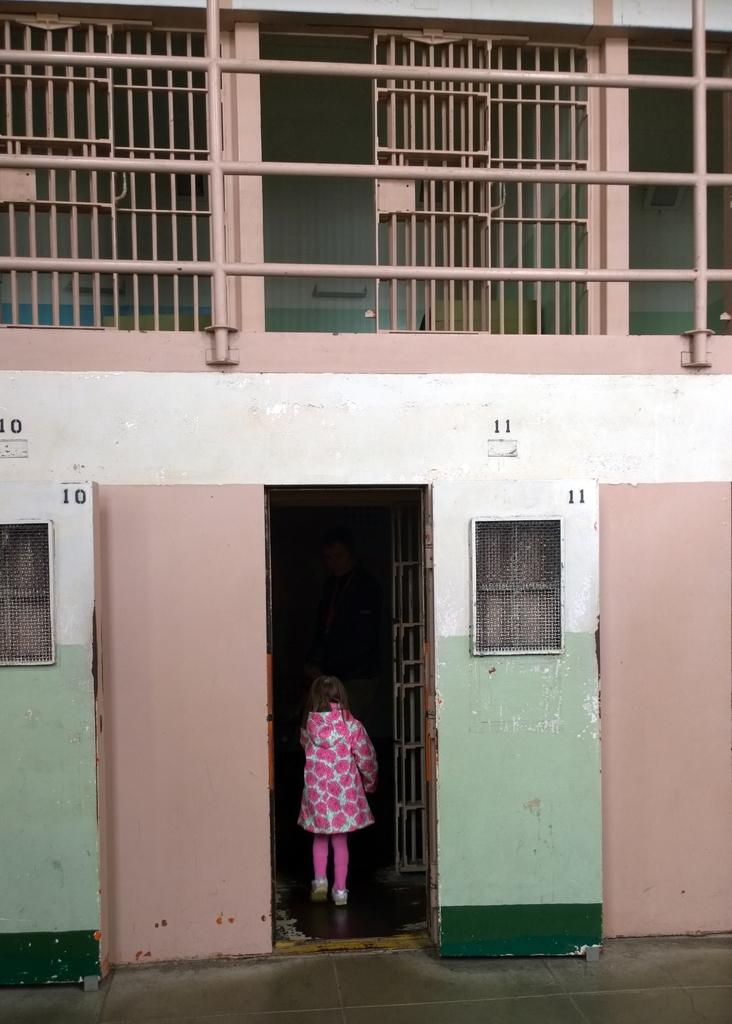Who or what is present in the image? There is a person in the image. What architectural feature can be seen in the image? There is a door in the image. What allows natural light to enter the space in the image? There are windows in the image. What type of barrier is visible in the image? There is a fence in the image. What type of markings are present on the wall in the image? There are numbers on the wall in the image. What type of beetle can be seen crawling on the fence in the image? There is no beetle present in the image; it only features a person, a door, windows, a fence, and numbers on the wall. 